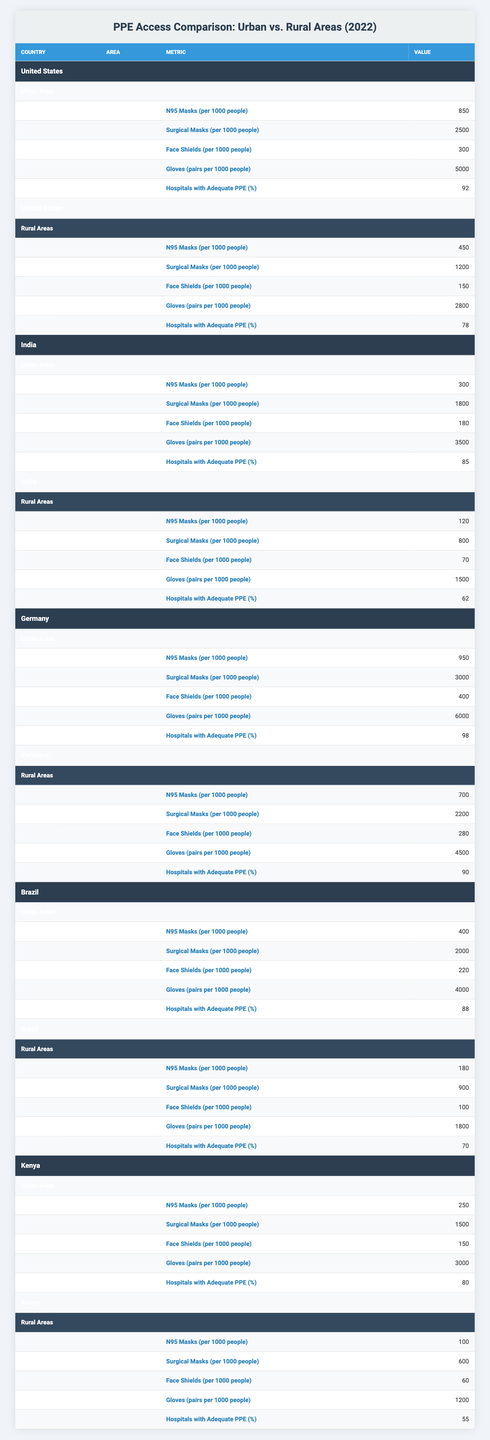What is the highest number of N95 masks provided per 1000 people in urban areas within the table? In the urban areas, the highest number of N95 masks provided per 1000 people is found in Germany with 950 masks.
Answer: 950 Which country has the lowest percentage of hospitals with adequate PPE in rural areas? In rural areas, the lowest percentage of hospitals with adequate PPE is found in Kenya at 55%.
Answer: 55% What is the difference in the number of surgical masks available per 1000 people between urban and rural areas in the United States? In the United States, urban areas have 2500 surgical masks per 1000 people while rural areas have 1200. The difference is 2500 - 1200 = 1300 masks.
Answer: 1300 Is there a country where rural areas have more masks per 1000 people than urban areas? No, all countries listed provide more masks per 1000 people in urban areas compared to rural areas.
Answer: No What is the average number of gloves provided per 1000 people in urban areas across all countries? The number of gloves in urban areas for each country is: United States (5000), India (3500), Germany (6000), Brazil (4000), and Kenya (3000). The total is 5000 + 3500 + 6000 + 4000 + 3000 = 21500 gloves. There are 5 data points, so the average is 21500 / 5 = 4300.
Answer: 4300 Which country shows the greatest increase in N95 masks from rural to urban areas? The increase in N95 masks is calculated as follows: United States: 850 - 450 = 400; India: 300 - 120 = 180; Germany: 950 - 700 = 250; Brazil: 400 - 180 = 220; Kenya: 250 - 100 = 150. The greatest increase is in the United States with 400 masks.
Answer: United States How many more face shields are provided per 1000 people in urban areas in Germany than in rural areas? In Germany, urban areas have 400 face shields per 1000 people, while rural areas have 280. The difference is 400 - 280 = 120 face shields.
Answer: 120 Which area (urban or rural) in Brazil has a higher availability of surgical masks per 1000 people? In Brazil, urban areas have 2000 surgical masks per 1000 people while rural areas have 900. Therefore, urban areas have a higher availability.
Answer: Urban areas What is the total number of N95 masks provided per 1000 people across all urban areas? The total for urban areas is: United States (850) + India (300) + Germany (950) + Brazil (400) + Kenya (250) = 2750 masks per 1000 people.
Answer: 2750 Which country has the highest percentage of hospitals with adequate PPE in urban areas and what is that percentage? In urban areas, Germany has the highest percentage of hospitals with adequate PPE at 98%.
Answer: 98 What is the median number of gloves provided per 1000 people in rural areas across all countries? The number of gloves in rural areas is: United States (2800), India (1500), Germany (4500), Brazil (1800), and Kenya (1200). When arranged, they are: 1200, 1500, 1800, 2800, 4500. The median value (the middle value) is 1800 gloves.
Answer: 1800 